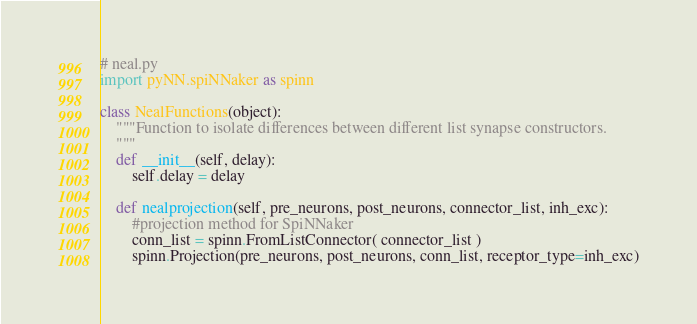<code> <loc_0><loc_0><loc_500><loc_500><_Python_># neal.py
import pyNN.spiNNaker as spinn

class NealFunctions(object):
    """Function to isolate differences between different list synapse constructors.
    """
    def __init__(self, delay):
        self.delay = delay
    
    def nealprojection(self, pre_neurons, post_neurons, connector_list, inh_exc):
        #projection method for SpiNNaker
        conn_list = spinn.FromListConnector( connector_list )
        spinn.Projection(pre_neurons, post_neurons, conn_list, receptor_type=inh_exc)
</code> 